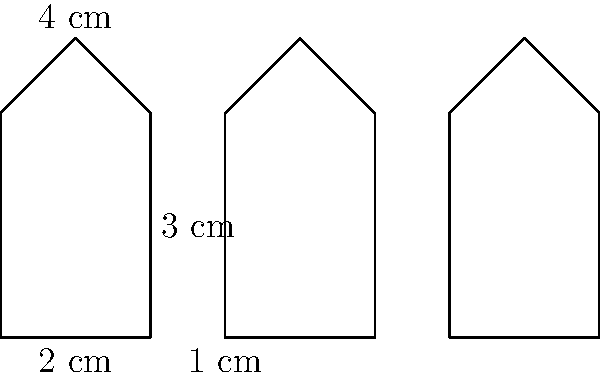For your next ASMR stream collaboration, you're designing a custom microphone setup. The arrangement forms an irregular polygon consisting of three microphone shapes, as shown in the diagram. Each microphone shape has a width of 2 cm and a height of 4 cm, with a slanted top edge. If the distance between each microphone is 1 cm, what is the perimeter of the entire arrangement in centimeters? Let's break this down step-by-step:

1) First, let's calculate the perimeter of a single microphone shape:
   Bottom: 2 cm
   Right side: 3 cm
   Slanted top: $\sqrt{1^2 + 1^2} = \sqrt{2}$ cm
   Left side: 3 cm
   Total for one microphone: $2 + 3 + \sqrt{2} + 3 = 8 + \sqrt{2}$ cm

2) Now, for the entire arrangement:
   - We have three microphones, but we don't simply multiply by 3.
   - The left side of the first microphone and the right side of the last microphone are fully exposed: $3 + 3 = 6$ cm
   - The bottom is continuous, including the gaps: $2 + 1 + 2 + 1 + 2 = 8$ cm
   - The top includes three slanted parts and two vertical parts:
     $3\sqrt{2} + 2 + 2 = 3\sqrt{2} + 4$ cm

3) Adding all these parts:
   Perimeter = $6 + 8 + (3\sqrt{2} + 4) = 18 + 3\sqrt{2}$ cm

Therefore, the perimeter of the entire microphone arrangement is $18 + 3\sqrt{2}$ cm.
Answer: $18 + 3\sqrt{2}$ cm 